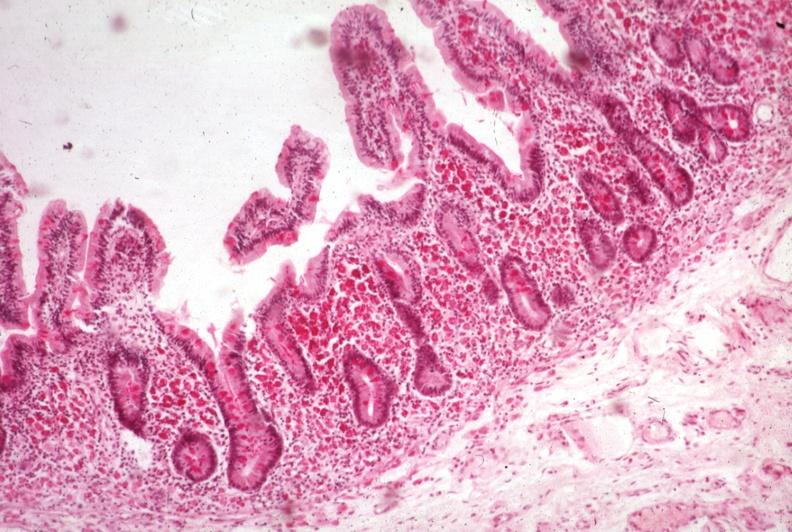where is this from?
Answer the question using a single word or phrase. Gastrointestinal system 